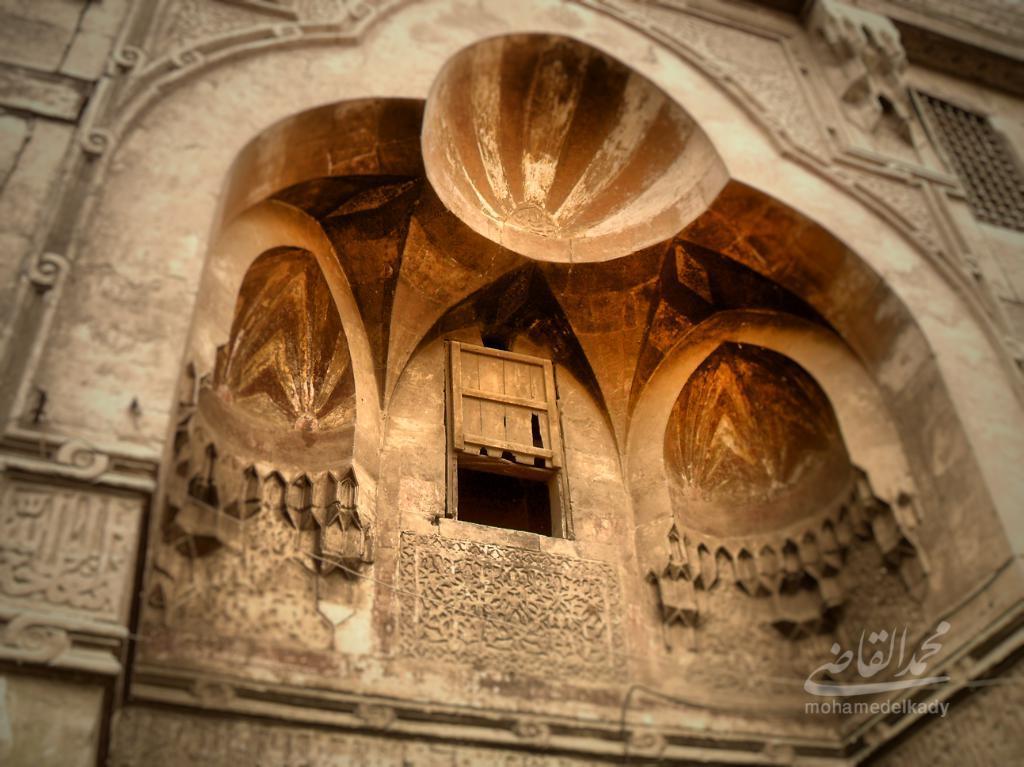In one or two sentences, can you explain what this image depicts? In this picture we can see a building with windows, wall with some carvings on it and at the bottom left corner we can see a watermark. 